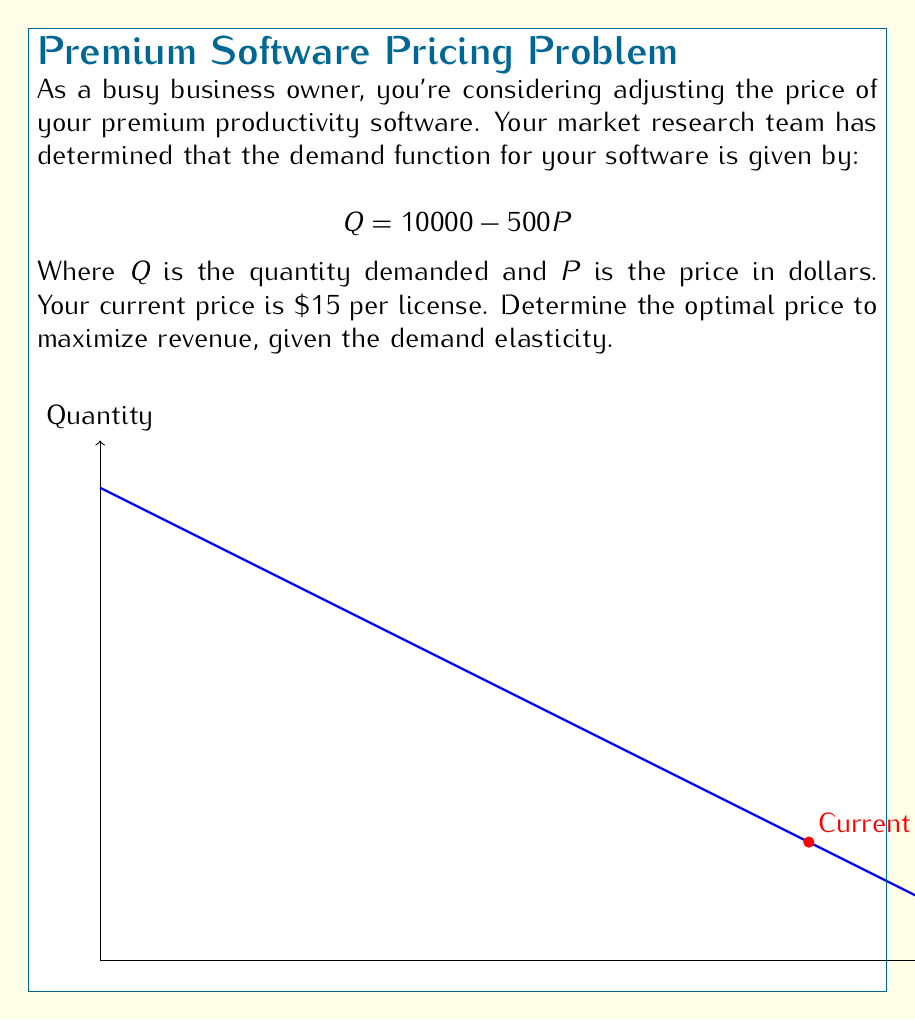What is the answer to this math problem? Let's approach this step-by-step:

1) First, we need to find the price elasticity of demand at the current price. The formula for price elasticity is:

   $$\epsilon = -\frac{\Delta Q}{\Delta P} \cdot \frac{P}{Q}$$

2) From the demand function, we can see that $\frac{\Delta Q}{\Delta P} = -500$. At the current price of $15:

   $$Q = 10000 - 500(15) = 2500$$

3) Now we can calculate the elasticity:

   $$\epsilon = -(-500) \cdot \frac{15}{2500} = 3$$

4) For revenue maximization, we want the elasticity to be exactly 1. This occurs at the midpoint of the demand curve.

5) To find the midpoint, we can use the formula:

   $$P = \frac{a}{2b}$$

   Where $a$ is the y-intercept (10000) and $b$ is the slope (-500).

6) Plugging in the values:

   $$P = \frac{10000}{2(-500)} = 10$$

7) We can verify this by calculating the quantity at this price:

   $$Q = 10000 - 500(10) = 5000$$

8) The revenue at this price is:

   $$R = P \cdot Q = 10 \cdot 5000 = 50000$$

This is indeed the maximum revenue point.
Answer: $10 per license 